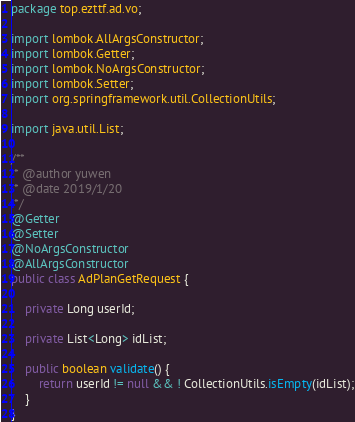Convert code to text. <code><loc_0><loc_0><loc_500><loc_500><_Java_>package top.ezttf.ad.vo;

import lombok.AllArgsConstructor;
import lombok.Getter;
import lombok.NoArgsConstructor;
import lombok.Setter;
import org.springframework.util.CollectionUtils;

import java.util.List;

/**
 * @author yuwen
 * @date 2019/1/20
 */
@Getter
@Setter
@NoArgsConstructor
@AllArgsConstructor
public class AdPlanGetRequest {

    private Long userId;

    private List<Long> idList;

    public boolean validate() {
        return userId != null && ! CollectionUtils.isEmpty(idList);
    }
}
</code> 